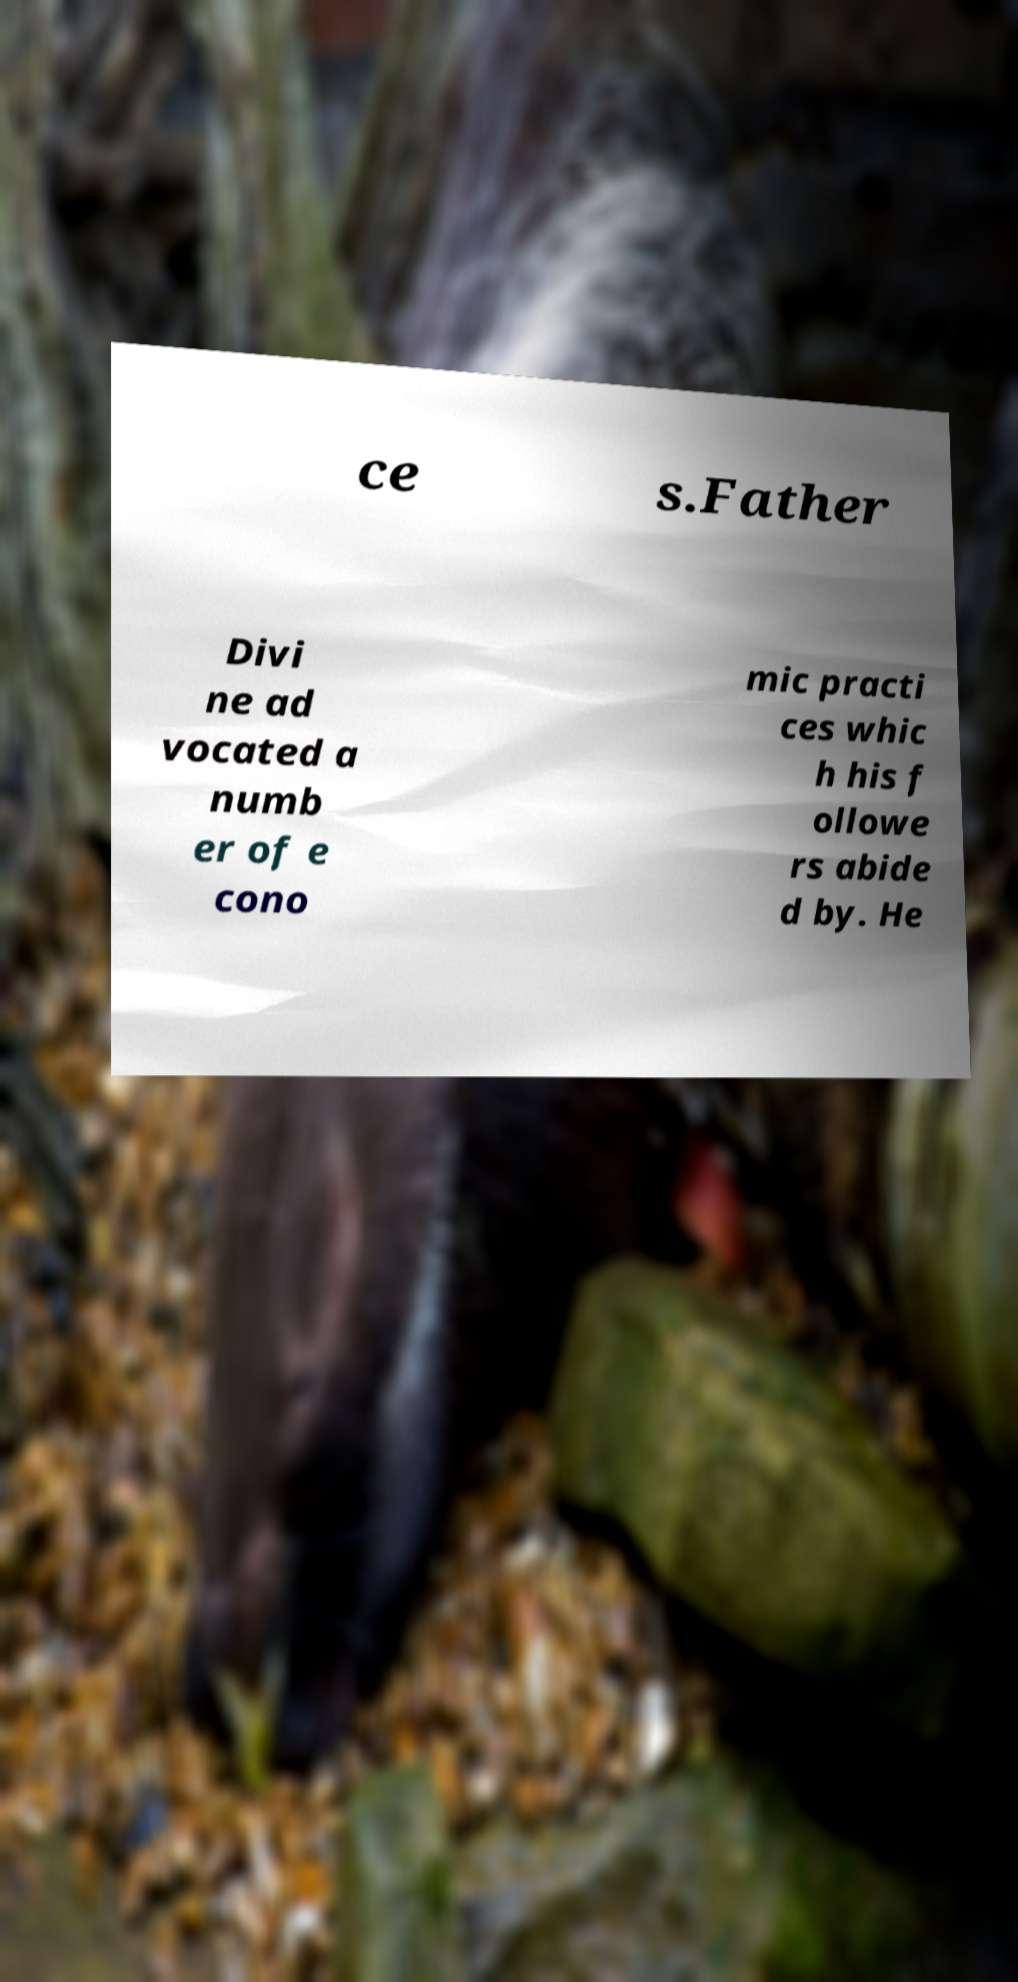I need the written content from this picture converted into text. Can you do that? ce s.Father Divi ne ad vocated a numb er of e cono mic practi ces whic h his f ollowe rs abide d by. He 